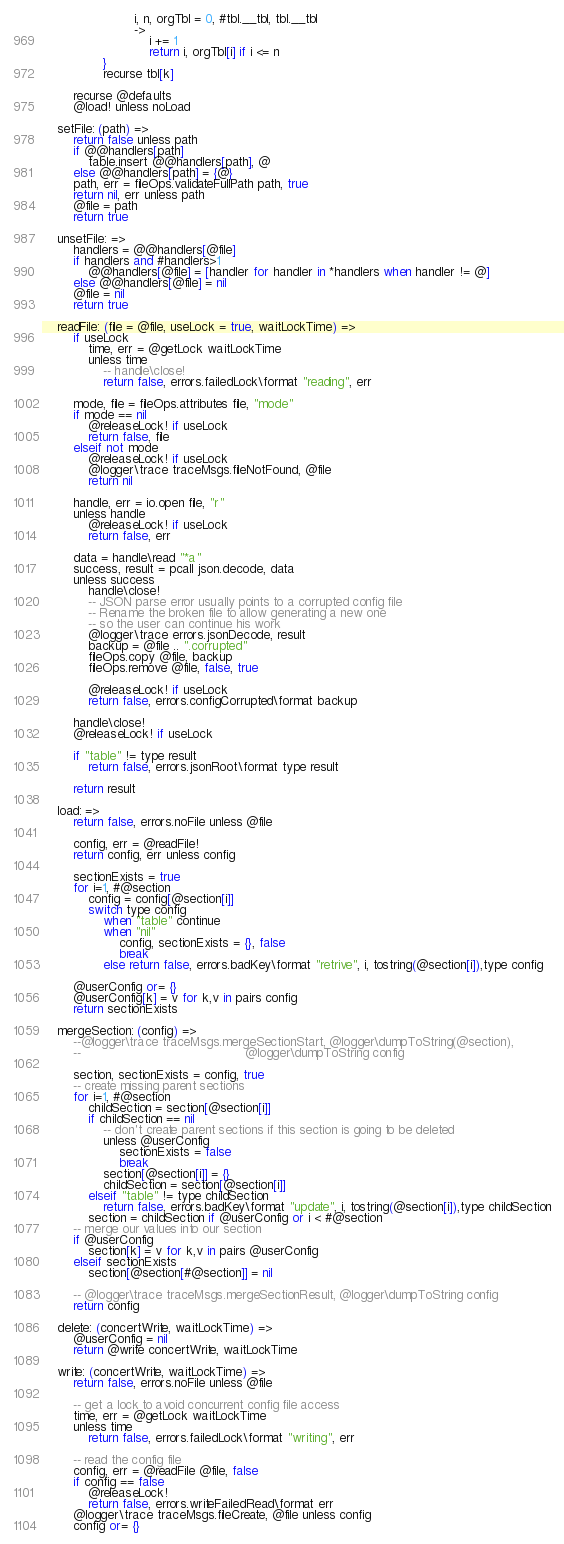<code> <loc_0><loc_0><loc_500><loc_500><_MoonScript_>                        i, n, orgTbl = 0, #tbl.__tbl, tbl.__tbl
                        ->
                            i += 1
                            return i, orgTbl[i] if i <= n
                }
                recurse tbl[k]

        recurse @defaults
        @load! unless noLoad

    setFile: (path) =>
        return false unless path
        if @@handlers[path]
            table.insert @@handlers[path], @
        else @@handlers[path] = {@}
        path, err = fileOps.validateFullPath path, true
        return nil, err unless path
        @file = path
        return true

    unsetFile: =>
        handlers = @@handlers[@file]
        if handlers and #handlers>1
            @@handlers[@file] = [handler for handler in *handlers when handler != @]
        else @@handlers[@file] = nil
        @file = nil
        return true

    readFile: (file = @file, useLock = true, waitLockTime) =>
        if useLock
            time, err = @getLock waitLockTime
            unless time
                -- handle\close!
                return false, errors.failedLock\format "reading", err

        mode, file = fileOps.attributes file, "mode"
        if mode == nil
            @releaseLock! if useLock
            return false, file
        elseif not mode
            @releaseLock! if useLock
            @logger\trace traceMsgs.fileNotFound, @file
            return nil

        handle, err = io.open file, "r"
        unless handle
            @releaseLock! if useLock
            return false, err

        data = handle\read "*a"
        success, result = pcall json.decode, data
        unless success
            handle\close!
            -- JSON parse error usually points to a corrupted config file
            -- Rename the broken file to allow generating a new one
            -- so the user can continue his work
            @logger\trace errors.jsonDecode, result
            backup = @file .. ".corrupted"
            fileOps.copy @file, backup
            fileOps.remove @file, false, true

            @releaseLock! if useLock
            return false, errors.configCorrupted\format backup

        handle\close!
        @releaseLock! if useLock

        if "table" != type result
            return false, errors.jsonRoot\format type result

        return result

    load: =>
        return false, errors.noFile unless @file

        config, err = @readFile!
        return config, err unless config

        sectionExists = true
        for i=1, #@section
            config = config[@section[i]]
            switch type config
                when "table" continue
                when "nil"
                    config, sectionExists = {}, false
                    break
                else return false, errors.badKey\format "retrive", i, tostring(@section[i]),type config

        @userConfig or= {}
        @userConfig[k] = v for k,v in pairs config
        return sectionExists

    mergeSection: (config) =>
        --@logger\trace traceMsgs.mergeSectionStart, @logger\dumpToString(@section),
        --                                           @logger\dumpToString config

        section, sectionExists = config, true
        -- create missing parent sections
        for i=1, #@section
            childSection = section[@section[i]]
            if childSection == nil
                -- don't create parent sections if this section is going to be deleted
                unless @userConfig
                    sectionExists = false
                    break
                section[@section[i]] = {}
                childSection = section[@section[i]]
            elseif "table" != type childSection
                return false, errors.badKey\format "update", i, tostring(@section[i]),type childSection
            section = childSection if @userConfig or i < #@section
        -- merge our values into our section
        if @userConfig
            section[k] = v for k,v in pairs @userConfig
        elseif sectionExists
            section[@section[#@section]] = nil

        -- @logger\trace traceMsgs.mergeSectionResult, @logger\dumpToString config
        return config

    delete: (concertWrite, waitLockTime) =>
        @userConfig = nil
        return @write concertWrite, waitLockTime

    write: (concertWrite, waitLockTime) =>
        return false, errors.noFile unless @file

        -- get a lock to avoid concurrent config file access
        time, err = @getLock waitLockTime
        unless time
            return false, errors.failedLock\format "writing", err

        -- read the config file
        config, err = @readFile @file, false
        if config == false
            @releaseLock!
            return false, errors.writeFailedRead\format err
        @logger\trace traceMsgs.fileCreate, @file unless config
        config or= {}
</code> 